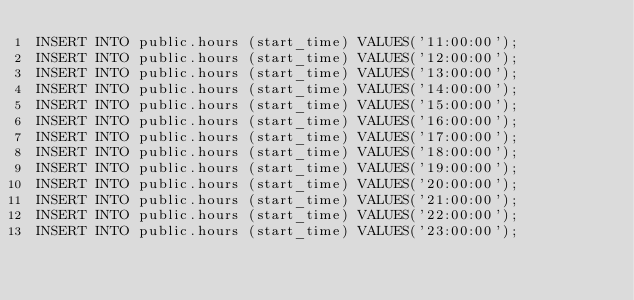<code> <loc_0><loc_0><loc_500><loc_500><_SQL_>INSERT INTO public.hours (start_time) VALUES('11:00:00');
INSERT INTO public.hours (start_time) VALUES('12:00:00');
INSERT INTO public.hours (start_time) VALUES('13:00:00');
INSERT INTO public.hours (start_time) VALUES('14:00:00');
INSERT INTO public.hours (start_time) VALUES('15:00:00');
INSERT INTO public.hours (start_time) VALUES('16:00:00');
INSERT INTO public.hours (start_time) VALUES('17:00:00');
INSERT INTO public.hours (start_time) VALUES('18:00:00');
INSERT INTO public.hours (start_time) VALUES('19:00:00');
INSERT INTO public.hours (start_time) VALUES('20:00:00');
INSERT INTO public.hours (start_time) VALUES('21:00:00');
INSERT INTO public.hours (start_time) VALUES('22:00:00');
INSERT INTO public.hours (start_time) VALUES('23:00:00');</code> 